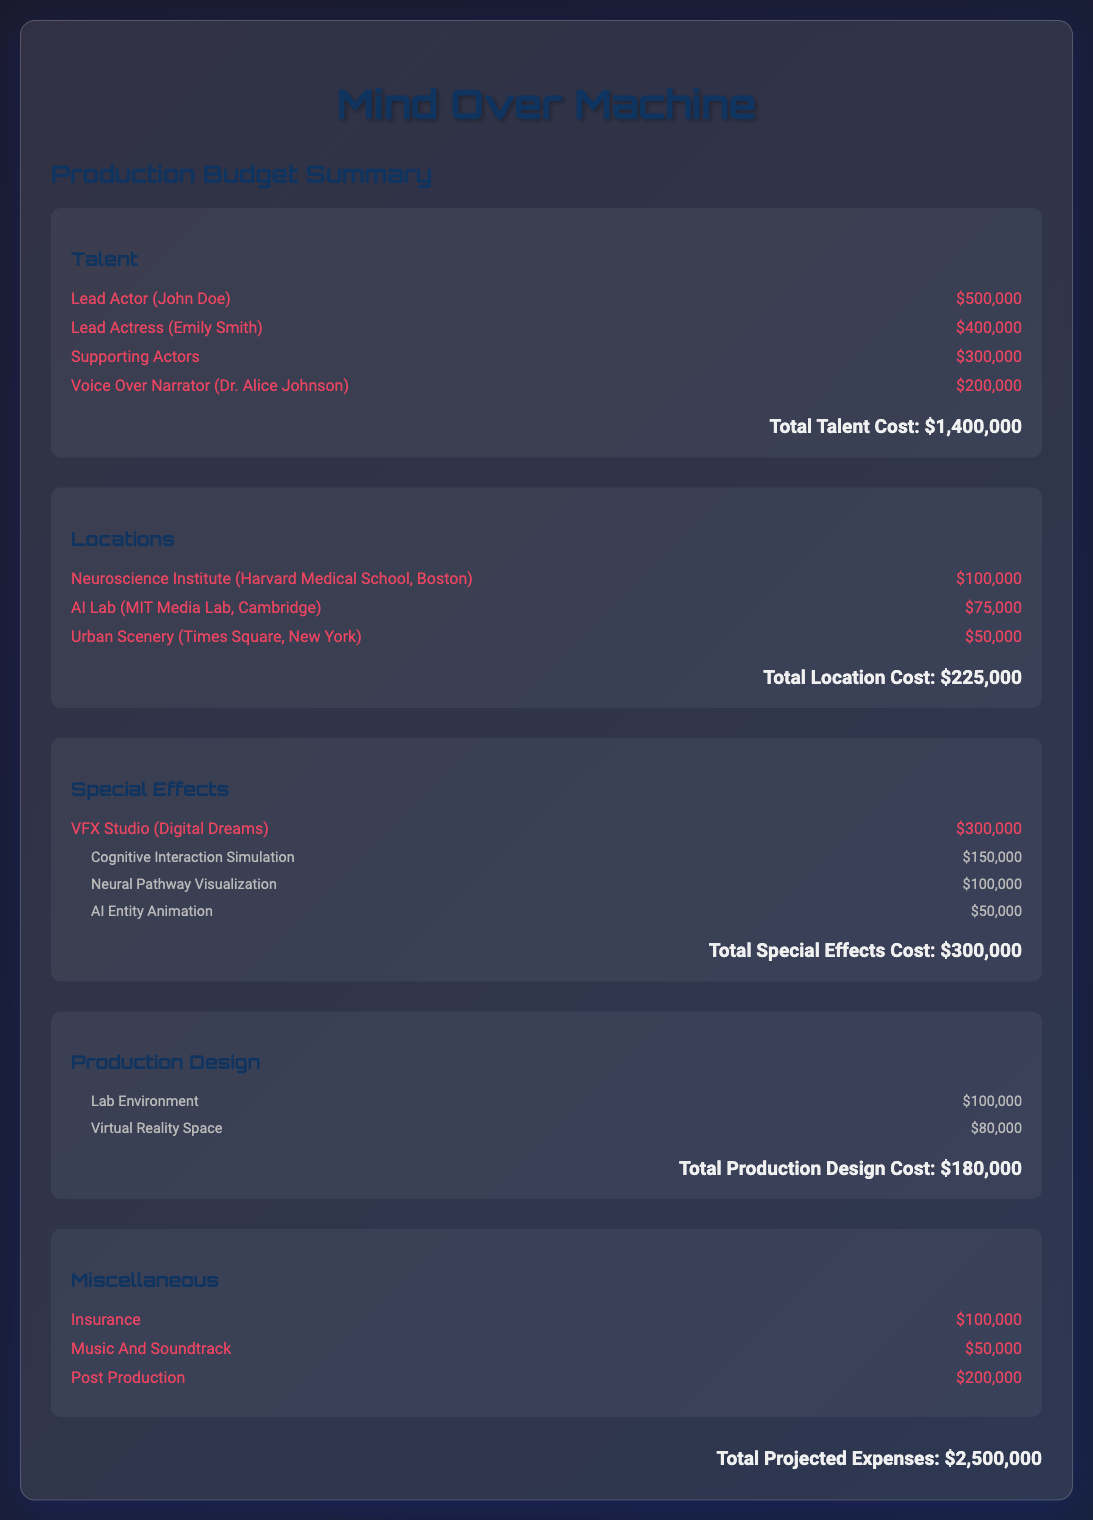What is the total talent cost? The total talent cost is the sum of all individual talent expenses in the budget, which is $500,000 + $400,000 + $300,000 + $200,000 = $1,400,000.
Answer: $1,400,000 What is the cost for the Neuroscience Institute location? The cost for the Neuroscience Institute (Harvard Medical School, Boston) is listed in the locations section as $100,000.
Answer: $100,000 How much is allocated for special effects? The total special effects cost is the sum of all special effects expenses, including the VFX studio and related simulations, amounting to $300,000.
Answer: $300,000 What is the budget for the Lead Actress? The budget for the Lead Actress, Emily Smith, is explicitly mentioned as $400,000 in the talent section.
Answer: $400,000 What is the total projected expenses for the film? Total projected expenses are indicated at the bottom of the document, summing all sections' costs, which is $2,500,000.
Answer: $2,500,000 What is the individual cost for the AI Entity Animation effect? The individual cost for the AI Entity Animation special effect is specifically listed as $50,000 in the special effects details.
Answer: $50,000 Which section has the highest individual cost? The talent section has the highest individual cost with the Lead Actor, John Doe, costing $500,000.
Answer: Talent How many locations are listed in the budget? There are three locations explicitly listed in the locations section: Neuroscience Institute, AI Lab, and Urban Scenery.
Answer: Three What is included under Miscellaneous costs? The Miscellaneous section includes Insurance, Music And Soundtrack, and Post Production, which contribute to the overall budget.
Answer: Insurance, Music And Soundtrack, Post Production 